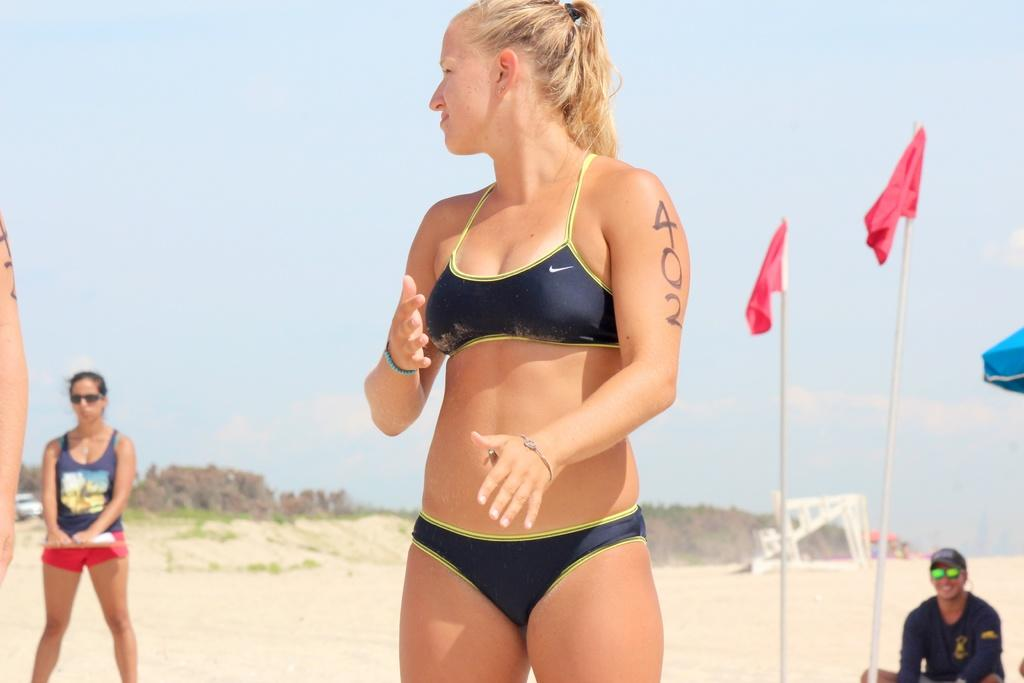What can be seen in the image? There are people, poles, flags, a car, sand, trees, and unspecified objects in the image. What is the background of the image? The sky is visible in the background of the image, with clouds present. What type of surface is the sand on? The sand is on the ground, as indicated by the presence of trees and poles. Can you see any bones in the wilderness depicted in the image? There is no wilderness depicted in the image, and therefore no bones can be seen. 